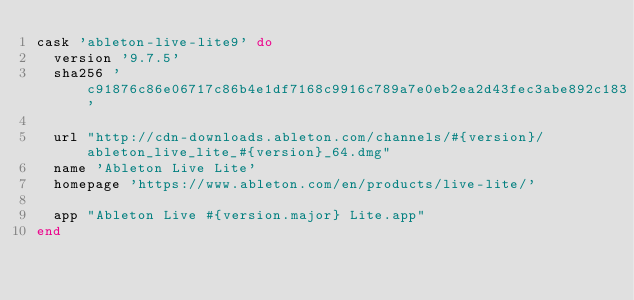<code> <loc_0><loc_0><loc_500><loc_500><_Ruby_>cask 'ableton-live-lite9' do
  version '9.7.5'
  sha256 'c91876c86e06717c86b4e1df7168c9916c789a7e0eb2ea2d43fec3abe892c183'

  url "http://cdn-downloads.ableton.com/channels/#{version}/ableton_live_lite_#{version}_64.dmg"
  name 'Ableton Live Lite'
  homepage 'https://www.ableton.com/en/products/live-lite/'

  app "Ableton Live #{version.major} Lite.app"
end
</code> 